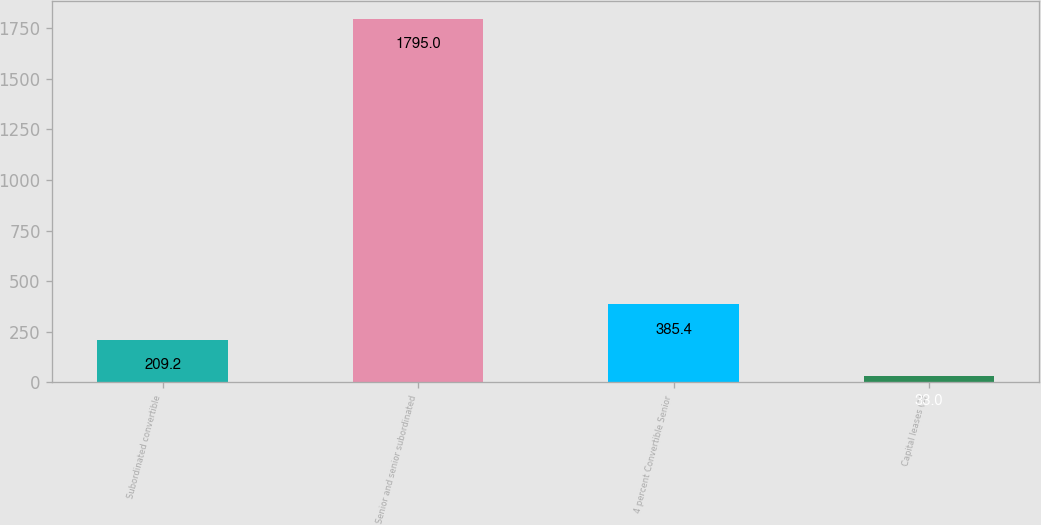Convert chart. <chart><loc_0><loc_0><loc_500><loc_500><bar_chart><fcel>Subordinated convertible<fcel>Senior and senior subordinated<fcel>4 percent Convertible Senior<fcel>Capital leases (2)<nl><fcel>209.2<fcel>1795<fcel>385.4<fcel>33<nl></chart> 